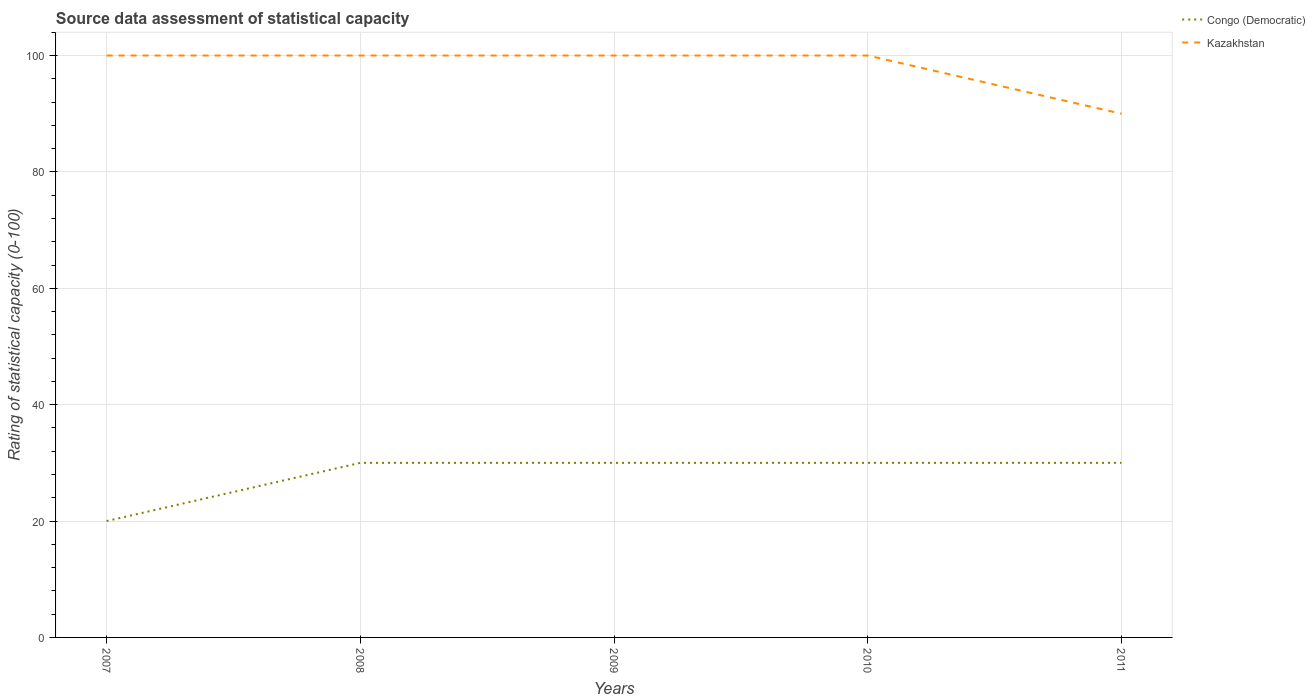Does the line corresponding to Kazakhstan intersect with the line corresponding to Congo (Democratic)?
Your answer should be very brief. No. Is the number of lines equal to the number of legend labels?
Offer a very short reply. Yes. Across all years, what is the maximum rating of statistical capacity in Kazakhstan?
Offer a terse response. 90. In which year was the rating of statistical capacity in Congo (Democratic) maximum?
Your answer should be very brief. 2007. What is the total rating of statistical capacity in Kazakhstan in the graph?
Provide a succinct answer. 10. What is the difference between the highest and the second highest rating of statistical capacity in Congo (Democratic)?
Provide a succinct answer. 10. Is the rating of statistical capacity in Kazakhstan strictly greater than the rating of statistical capacity in Congo (Democratic) over the years?
Make the answer very short. No. How many lines are there?
Make the answer very short. 2. How many years are there in the graph?
Offer a terse response. 5. What is the difference between two consecutive major ticks on the Y-axis?
Ensure brevity in your answer.  20. Are the values on the major ticks of Y-axis written in scientific E-notation?
Provide a short and direct response. No. Does the graph contain grids?
Your answer should be compact. Yes. Where does the legend appear in the graph?
Give a very brief answer. Top right. How many legend labels are there?
Ensure brevity in your answer.  2. How are the legend labels stacked?
Ensure brevity in your answer.  Vertical. What is the title of the graph?
Give a very brief answer. Source data assessment of statistical capacity. Does "Euro area" appear as one of the legend labels in the graph?
Offer a very short reply. No. What is the label or title of the X-axis?
Make the answer very short. Years. What is the label or title of the Y-axis?
Make the answer very short. Rating of statistical capacity (0-100). What is the Rating of statistical capacity (0-100) of Congo (Democratic) in 2007?
Offer a very short reply. 20. What is the Rating of statistical capacity (0-100) in Kazakhstan in 2007?
Offer a terse response. 100. What is the Rating of statistical capacity (0-100) in Congo (Democratic) in 2008?
Offer a terse response. 30. What is the Rating of statistical capacity (0-100) of Congo (Democratic) in 2010?
Provide a succinct answer. 30. What is the Rating of statistical capacity (0-100) in Kazakhstan in 2011?
Provide a succinct answer. 90. Across all years, what is the maximum Rating of statistical capacity (0-100) of Kazakhstan?
Offer a terse response. 100. What is the total Rating of statistical capacity (0-100) of Congo (Democratic) in the graph?
Offer a terse response. 140. What is the total Rating of statistical capacity (0-100) of Kazakhstan in the graph?
Your answer should be very brief. 490. What is the difference between the Rating of statistical capacity (0-100) in Congo (Democratic) in 2007 and that in 2008?
Provide a succinct answer. -10. What is the difference between the Rating of statistical capacity (0-100) of Congo (Democratic) in 2007 and that in 2009?
Make the answer very short. -10. What is the difference between the Rating of statistical capacity (0-100) of Kazakhstan in 2007 and that in 2009?
Make the answer very short. 0. What is the difference between the Rating of statistical capacity (0-100) in Congo (Democratic) in 2007 and that in 2010?
Your response must be concise. -10. What is the difference between the Rating of statistical capacity (0-100) of Kazakhstan in 2007 and that in 2011?
Your answer should be very brief. 10. What is the difference between the Rating of statistical capacity (0-100) of Congo (Democratic) in 2008 and that in 2009?
Make the answer very short. 0. What is the difference between the Rating of statistical capacity (0-100) in Kazakhstan in 2008 and that in 2009?
Give a very brief answer. 0. What is the difference between the Rating of statistical capacity (0-100) of Congo (Democratic) in 2008 and that in 2010?
Provide a succinct answer. 0. What is the difference between the Rating of statistical capacity (0-100) of Kazakhstan in 2008 and that in 2010?
Your response must be concise. 0. What is the difference between the Rating of statistical capacity (0-100) of Congo (Democratic) in 2008 and that in 2011?
Your response must be concise. 0. What is the difference between the Rating of statistical capacity (0-100) in Congo (Democratic) in 2009 and that in 2010?
Keep it short and to the point. 0. What is the difference between the Rating of statistical capacity (0-100) in Kazakhstan in 2009 and that in 2010?
Make the answer very short. 0. What is the difference between the Rating of statistical capacity (0-100) in Congo (Democratic) in 2010 and that in 2011?
Provide a succinct answer. 0. What is the difference between the Rating of statistical capacity (0-100) in Kazakhstan in 2010 and that in 2011?
Your answer should be compact. 10. What is the difference between the Rating of statistical capacity (0-100) in Congo (Democratic) in 2007 and the Rating of statistical capacity (0-100) in Kazakhstan in 2008?
Your response must be concise. -80. What is the difference between the Rating of statistical capacity (0-100) in Congo (Democratic) in 2007 and the Rating of statistical capacity (0-100) in Kazakhstan in 2009?
Your answer should be compact. -80. What is the difference between the Rating of statistical capacity (0-100) of Congo (Democratic) in 2007 and the Rating of statistical capacity (0-100) of Kazakhstan in 2010?
Your answer should be very brief. -80. What is the difference between the Rating of statistical capacity (0-100) of Congo (Democratic) in 2007 and the Rating of statistical capacity (0-100) of Kazakhstan in 2011?
Your response must be concise. -70. What is the difference between the Rating of statistical capacity (0-100) of Congo (Democratic) in 2008 and the Rating of statistical capacity (0-100) of Kazakhstan in 2009?
Make the answer very short. -70. What is the difference between the Rating of statistical capacity (0-100) of Congo (Democratic) in 2008 and the Rating of statistical capacity (0-100) of Kazakhstan in 2010?
Offer a terse response. -70. What is the difference between the Rating of statistical capacity (0-100) of Congo (Democratic) in 2008 and the Rating of statistical capacity (0-100) of Kazakhstan in 2011?
Ensure brevity in your answer.  -60. What is the difference between the Rating of statistical capacity (0-100) in Congo (Democratic) in 2009 and the Rating of statistical capacity (0-100) in Kazakhstan in 2010?
Keep it short and to the point. -70. What is the difference between the Rating of statistical capacity (0-100) in Congo (Democratic) in 2009 and the Rating of statistical capacity (0-100) in Kazakhstan in 2011?
Provide a short and direct response. -60. What is the difference between the Rating of statistical capacity (0-100) of Congo (Democratic) in 2010 and the Rating of statistical capacity (0-100) of Kazakhstan in 2011?
Your answer should be very brief. -60. What is the average Rating of statistical capacity (0-100) in Congo (Democratic) per year?
Provide a succinct answer. 28. In the year 2007, what is the difference between the Rating of statistical capacity (0-100) of Congo (Democratic) and Rating of statistical capacity (0-100) of Kazakhstan?
Offer a terse response. -80. In the year 2008, what is the difference between the Rating of statistical capacity (0-100) in Congo (Democratic) and Rating of statistical capacity (0-100) in Kazakhstan?
Your response must be concise. -70. In the year 2009, what is the difference between the Rating of statistical capacity (0-100) of Congo (Democratic) and Rating of statistical capacity (0-100) of Kazakhstan?
Offer a very short reply. -70. In the year 2010, what is the difference between the Rating of statistical capacity (0-100) of Congo (Democratic) and Rating of statistical capacity (0-100) of Kazakhstan?
Offer a terse response. -70. In the year 2011, what is the difference between the Rating of statistical capacity (0-100) of Congo (Democratic) and Rating of statistical capacity (0-100) of Kazakhstan?
Your response must be concise. -60. What is the ratio of the Rating of statistical capacity (0-100) of Congo (Democratic) in 2007 to that in 2008?
Keep it short and to the point. 0.67. What is the ratio of the Rating of statistical capacity (0-100) of Kazakhstan in 2007 to that in 2008?
Ensure brevity in your answer.  1. What is the ratio of the Rating of statistical capacity (0-100) of Kazakhstan in 2007 to that in 2009?
Ensure brevity in your answer.  1. What is the ratio of the Rating of statistical capacity (0-100) of Congo (Democratic) in 2007 to that in 2010?
Your response must be concise. 0.67. What is the ratio of the Rating of statistical capacity (0-100) in Congo (Democratic) in 2007 to that in 2011?
Keep it short and to the point. 0.67. What is the ratio of the Rating of statistical capacity (0-100) in Kazakhstan in 2007 to that in 2011?
Make the answer very short. 1.11. What is the ratio of the Rating of statistical capacity (0-100) in Kazakhstan in 2008 to that in 2009?
Your answer should be compact. 1. What is the ratio of the Rating of statistical capacity (0-100) of Kazakhstan in 2009 to that in 2010?
Your response must be concise. 1. What is the ratio of the Rating of statistical capacity (0-100) in Congo (Democratic) in 2009 to that in 2011?
Provide a succinct answer. 1. What is the ratio of the Rating of statistical capacity (0-100) in Kazakhstan in 2009 to that in 2011?
Provide a short and direct response. 1.11. What is the ratio of the Rating of statistical capacity (0-100) of Congo (Democratic) in 2010 to that in 2011?
Keep it short and to the point. 1. What is the difference between the highest and the second highest Rating of statistical capacity (0-100) in Congo (Democratic)?
Provide a short and direct response. 0. What is the difference between the highest and the lowest Rating of statistical capacity (0-100) in Congo (Democratic)?
Your response must be concise. 10. What is the difference between the highest and the lowest Rating of statistical capacity (0-100) in Kazakhstan?
Keep it short and to the point. 10. 